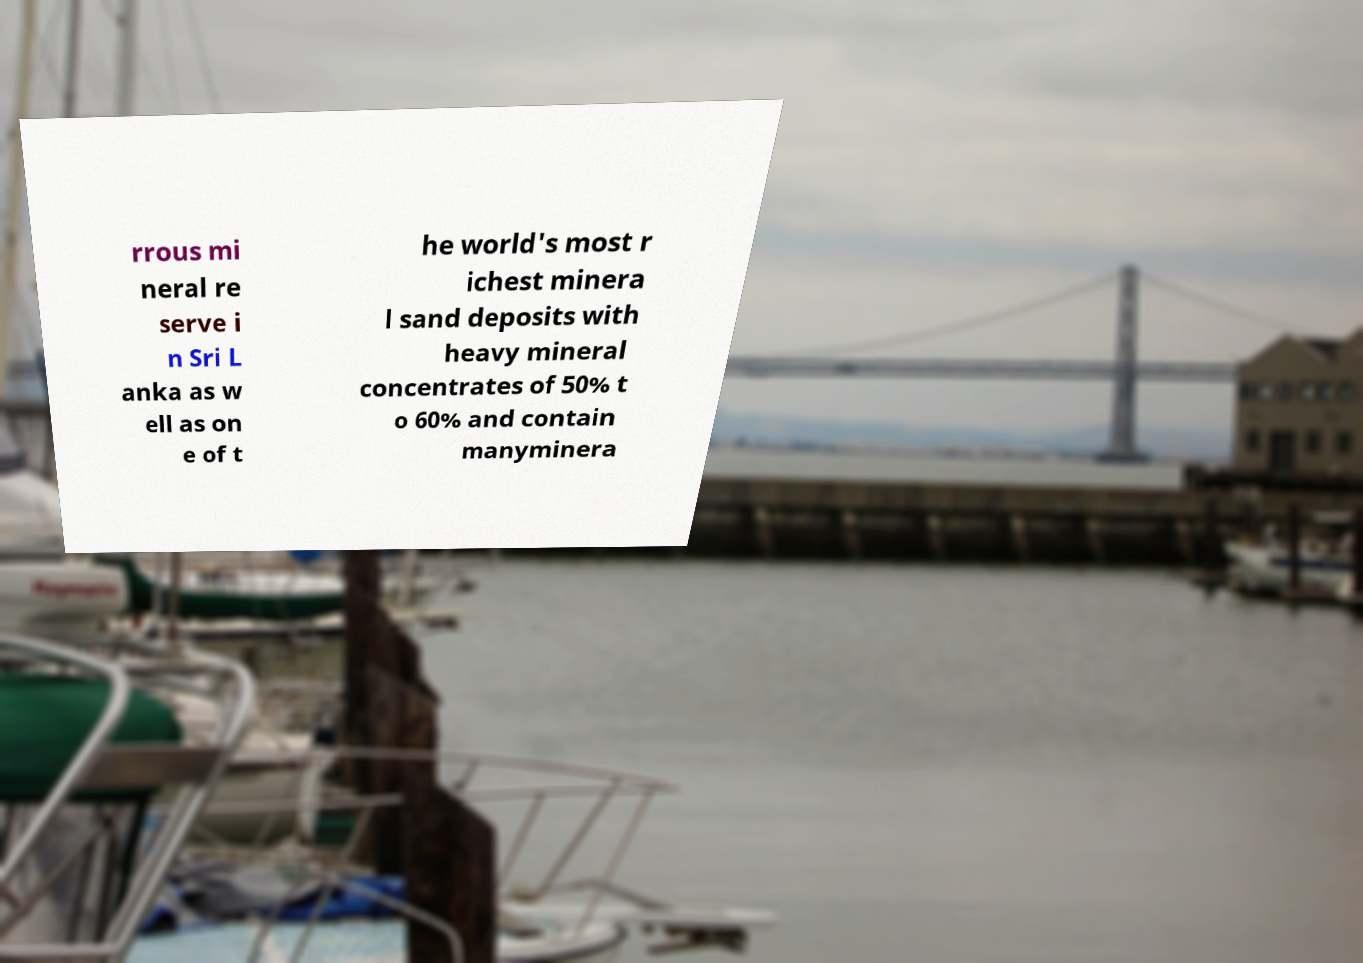Can you accurately transcribe the text from the provided image for me? rrous mi neral re serve i n Sri L anka as w ell as on e of t he world's most r ichest minera l sand deposits with heavy mineral concentrates of 50% t o 60% and contain manyminera 